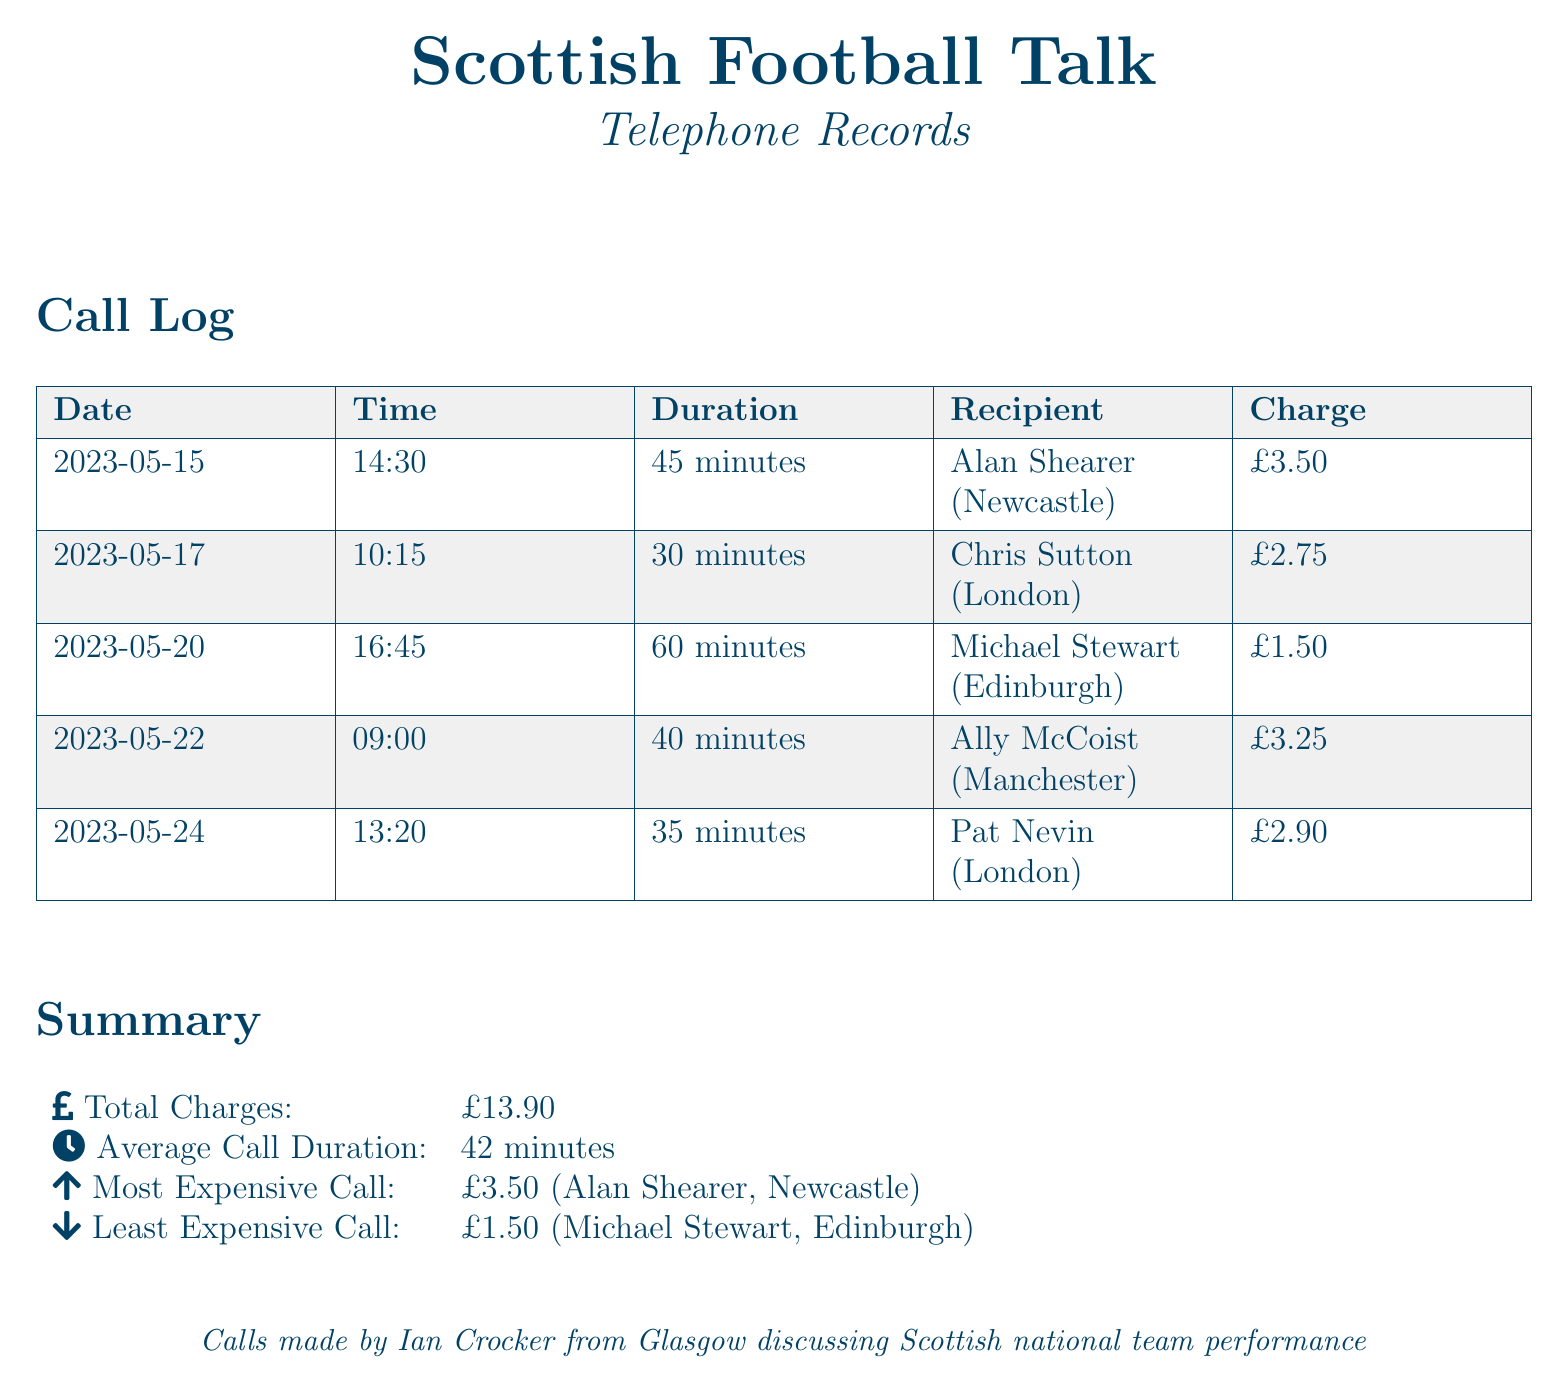What is the total charge for all calls? The total charge is listed in the summary section, which sums up all individual call charges to £13.90.
Answer: £13.90 Who is the recipient of the most expensive call? The most expensive call is specified in the summary, indicating that Alan Shearer from Newcastle was the recipient of this call.
Answer: Alan Shearer (Newcastle) What was the duration of the call with Chris Sutton? The duration is included in the call log for Chris Sutton, which details that the conversation lasted 30 minutes.
Answer: 30 minutes What is the average call duration? The average call duration is summarized in the document as the average length of all calls, which is calculated to be 42 minutes.
Answer: 42 minutes Which recipient had the least expensive call? The least expensive call is indicated in the summary as Michael Stewart from Edinburgh, who was the recipient of this call.
Answer: Michael Stewart (Edinburgh) How many minutes long was the call with Ally McCoist? The length of the call with Ally McCoist is recorded in the log as lasting for 40 minutes.
Answer: 40 minutes What was the charge for the call with Pat Nevin? The charge for Pat Nevin's call is specifically listed in the call log as £2.90.
Answer: £2.90 Which date was the call with Michael Stewart made? The date for the call with Michael Stewart is provided in the log and noted as May 20, 2023.
Answer: 2023-05-20 